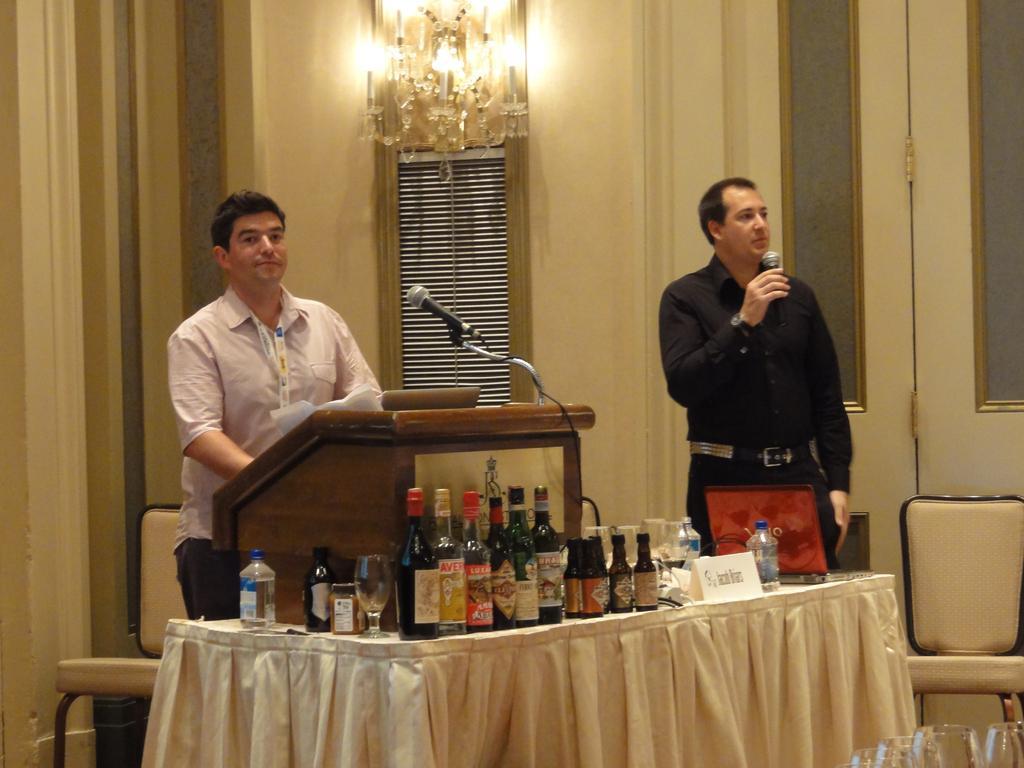Please provide a concise description of this image. In this picture two people holding the mikes and standing in front of the desk and on the table we have some bottles. 